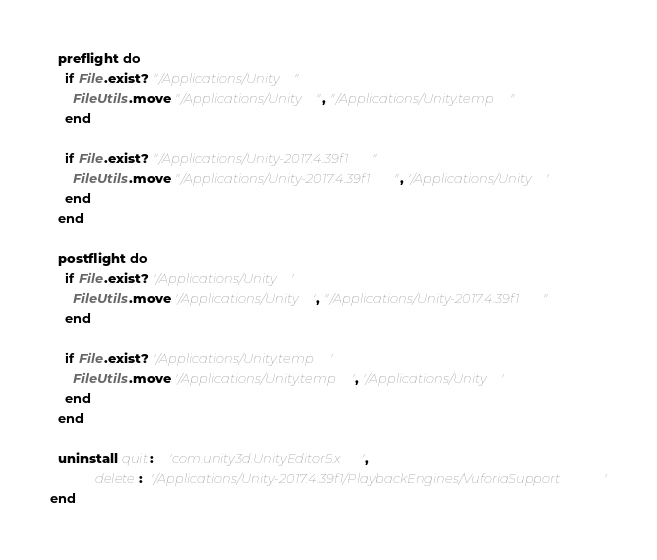<code> <loc_0><loc_0><loc_500><loc_500><_Ruby_>  preflight do
    if File.exist? "/Applications/Unity"
      FileUtils.move "/Applications/Unity", "/Applications/Unity.temp"
    end

    if File.exist? "/Applications/Unity-2017.4.39f1"
      FileUtils.move "/Applications/Unity-2017.4.39f1", '/Applications/Unity'
    end
  end

  postflight do
    if File.exist? '/Applications/Unity'
      FileUtils.move '/Applications/Unity', "/Applications/Unity-2017.4.39f1"
    end

    if File.exist? '/Applications/Unity.temp'
      FileUtils.move '/Applications/Unity.temp', '/Applications/Unity'
    end
  end

  uninstall quit:    'com.unity3d.UnityEditor5.x',
            delete:  '/Applications/Unity-2017.4.39f1/PlaybackEngines/VuforiaSupport'
end
</code> 